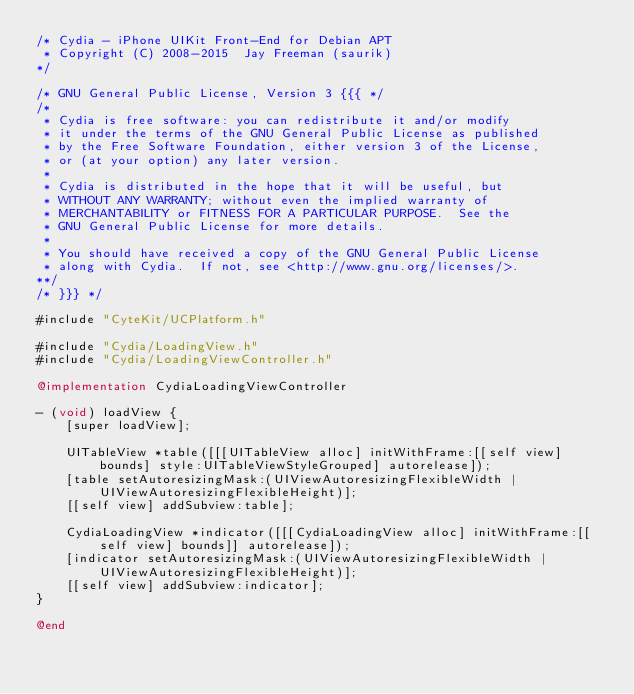Convert code to text. <code><loc_0><loc_0><loc_500><loc_500><_ObjectiveC_>/* Cydia - iPhone UIKit Front-End for Debian APT
 * Copyright (C) 2008-2015  Jay Freeman (saurik)
*/

/* GNU General Public License, Version 3 {{{ */
/*
 * Cydia is free software: you can redistribute it and/or modify
 * it under the terms of the GNU General Public License as published
 * by the Free Software Foundation, either version 3 of the License,
 * or (at your option) any later version.
 *
 * Cydia is distributed in the hope that it will be useful, but
 * WITHOUT ANY WARRANTY; without even the implied warranty of
 * MERCHANTABILITY or FITNESS FOR A PARTICULAR PURPOSE.  See the
 * GNU General Public License for more details.
 *
 * You should have received a copy of the GNU General Public License
 * along with Cydia.  If not, see <http://www.gnu.org/licenses/>.
**/
/* }}} */

#include "CyteKit/UCPlatform.h"

#include "Cydia/LoadingView.h"
#include "Cydia/LoadingViewController.h"

@implementation CydiaLoadingViewController

- (void) loadView {
    [super loadView];

    UITableView *table([[[UITableView alloc] initWithFrame:[[self view] bounds] style:UITableViewStyleGrouped] autorelease]);
    [table setAutoresizingMask:(UIViewAutoresizingFlexibleWidth | UIViewAutoresizingFlexibleHeight)];
    [[self view] addSubview:table];

    CydiaLoadingView *indicator([[[CydiaLoadingView alloc] initWithFrame:[[self view] bounds]] autorelease]);
    [indicator setAutoresizingMask:(UIViewAutoresizingFlexibleWidth | UIViewAutoresizingFlexibleHeight)];
    [[self view] addSubview:indicator];
}

@end
</code> 